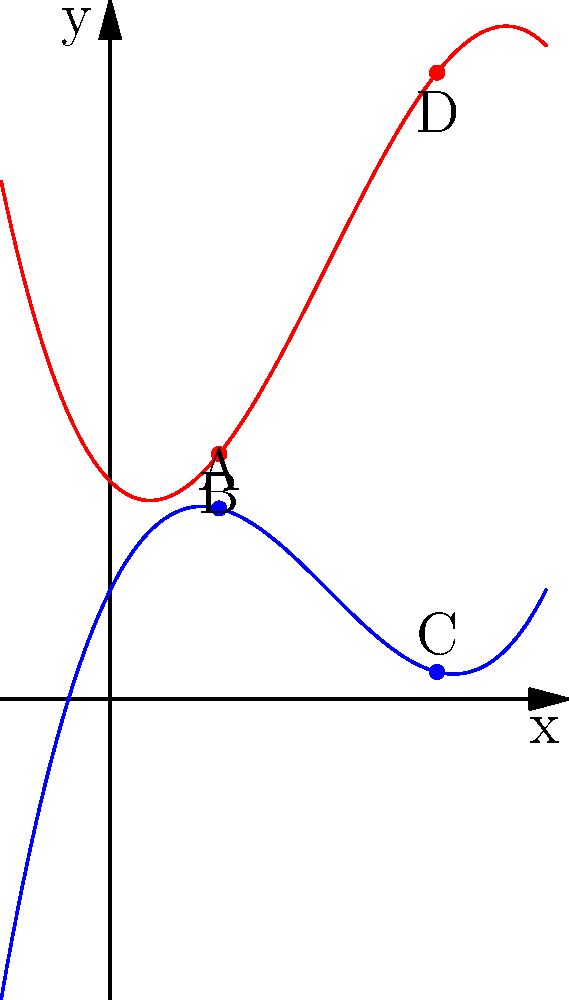As a discerning customer who has been through numerous insurance agents, you've developed a keen eye for detail in rate comparisons. Consider the graph above showing two polynomial functions, $f(x)$ (blue) and $g(x)$ (red). At which point, A, B, C, or D, is the rate of change of $f(x)$ greater than the rate of change of $g(x)$ by the largest margin? Justify your answer with precise calculations. To solve this problem, we need to compare the rates of change (derivatives) of $f(x)$ and $g(x)$ at points A, B, C, and D. Let's approach this step-by-step:

1) First, we need to find the derivatives of $f(x)$ and $g(x)$:
   $f'(x) = 0.75x^2 - 3x + 2$
   $g'(x) = -0.75x^2 + 3x - 1$

2) Now, let's calculate the derivatives at x = 1 (points A and B) and x = 3 (points C and D):

   At x = 1:
   $f'(1) = 0.75(1)^2 - 3(1) + 2 = -0.25$
   $g'(1) = -0.75(1)^2 + 3(1) - 1 = 1.25$
   Difference: $f'(1) - g'(1) = -0.25 - 1.25 = -1.5$

   At x = 3:
   $f'(3) = 0.75(3)^2 - 3(3) + 2 = 2.75$
   $g'(3) = -0.75(3)^2 + 3(3) - 1 = -2.75$
   Difference: $f'(3) - g'(3) = 2.75 - (-2.75) = 5.5$

3) We're looking for the point where $f'(x)$ exceeds $g'(x)$ by the largest margin. This occurs where the difference $f'(x) - g'(x)$ is largest.

4) Comparing the differences:
   At x = 1: -1.5
   At x = 3: 5.5

5) The larger difference is at x = 3, which corresponds to points C and D.

Therefore, the rate of change of $f(x)$ is greater than the rate of change of $g(x)$ by the largest margin at point C.
Answer: Point C 